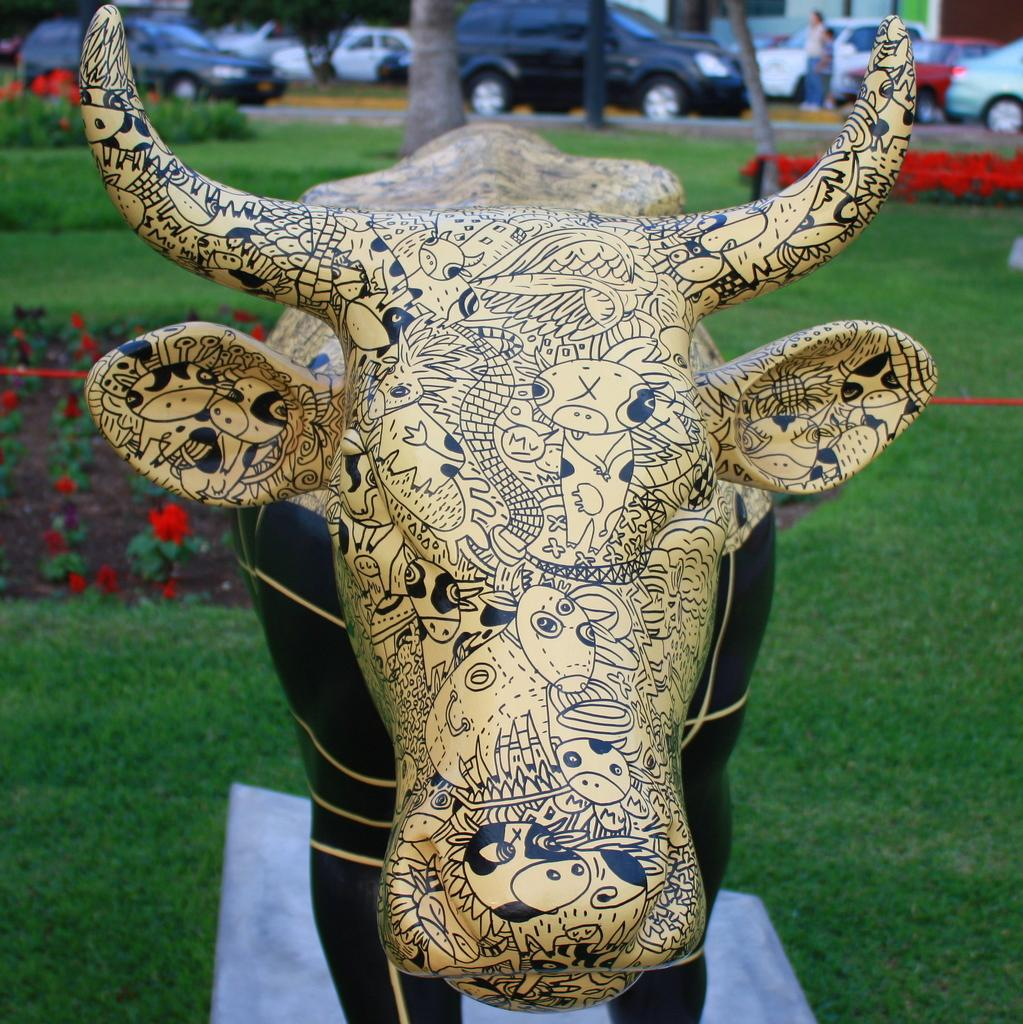What animal is the main subject of the image? There is a bull in the image. What type of vegetation is present at the bottom of the image? There is green grass at the bottom of the image. What can be seen in the background of the image? There are many flowers in red color and cars parked on the road in the background of the image. What invention is being used by the servant in the image? There is no servant or invention present in the image. 